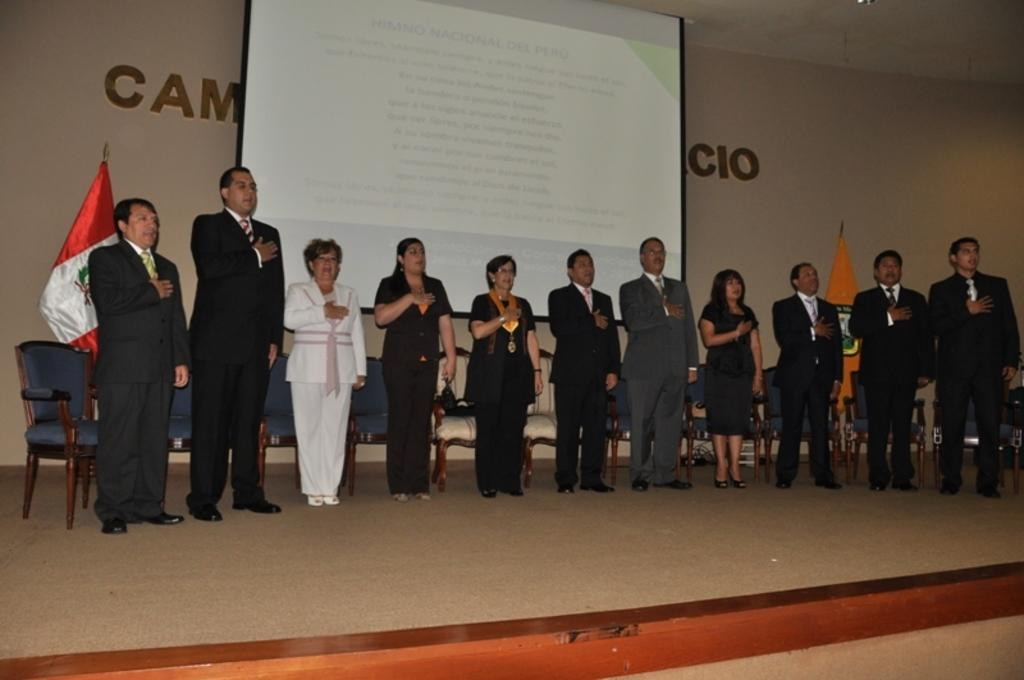What can be seen in the image involving people? There are people standing in the image. What objects are present for sitting? There are chairs in the image. What symbolic items are visible in the image? There are flags in the image. What can be seen on the wall in the background of the image? There is text on a wall in the background of the image. What type of display device is present in the background? There is a screen in the background of the image. How many frogs are jumping on the screen in the image? There are no frogs present in the image, and therefore no such activity can be observed. 